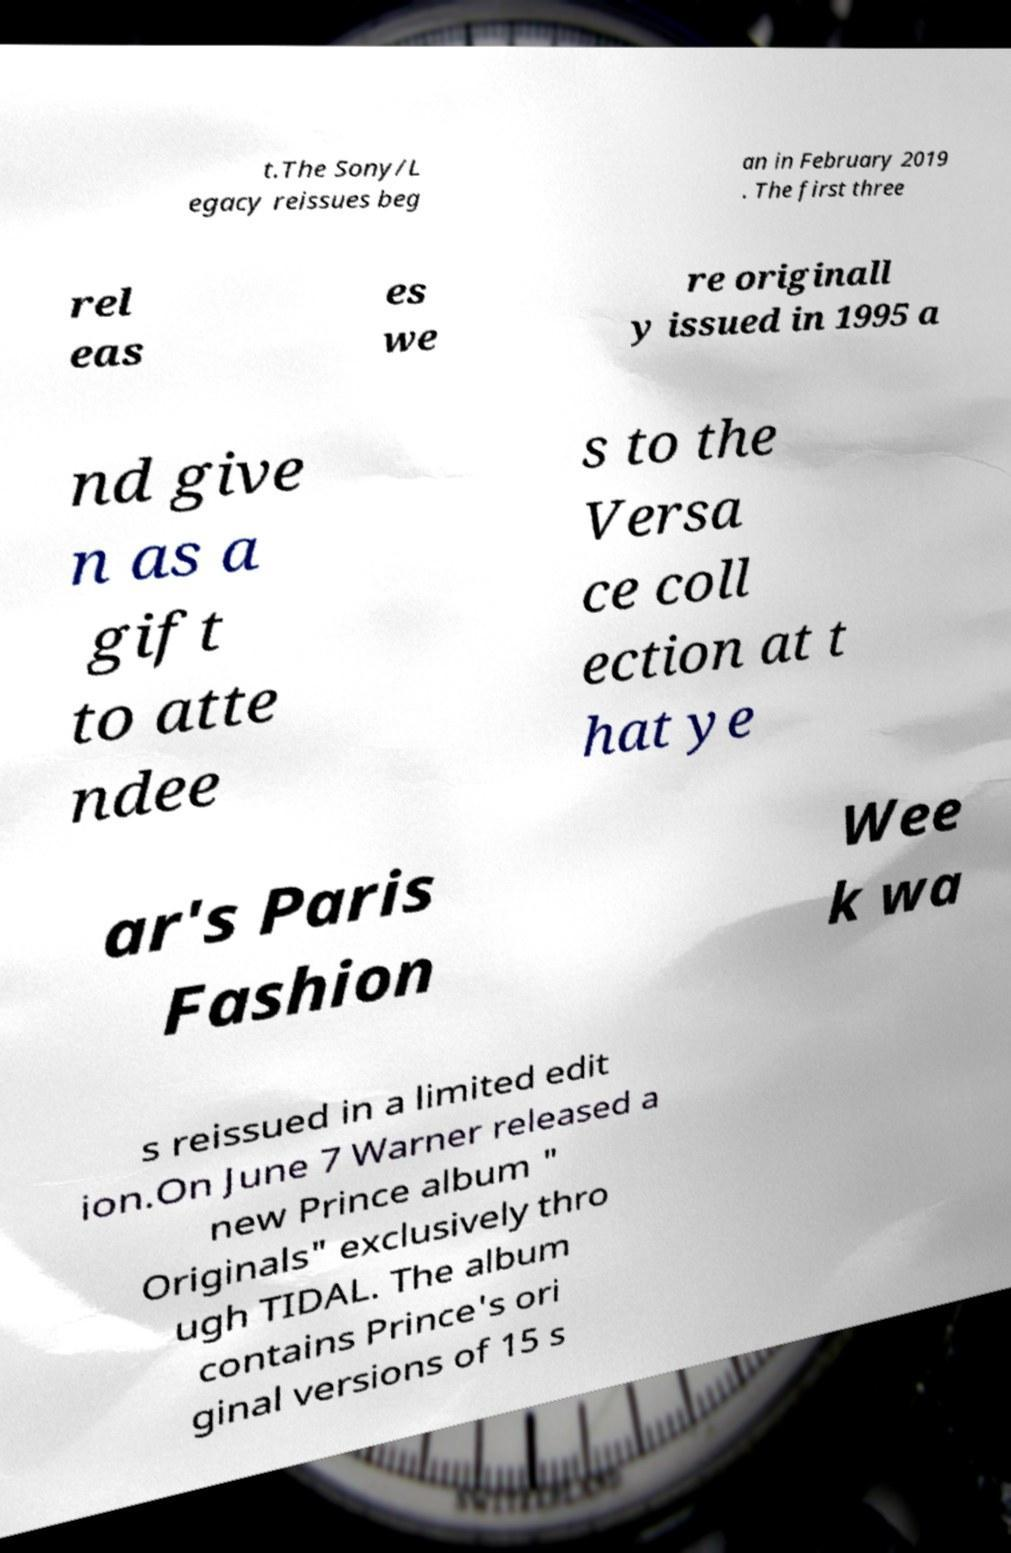Please read and relay the text visible in this image. What does it say? t.The Sony/L egacy reissues beg an in February 2019 . The first three rel eas es we re originall y issued in 1995 a nd give n as a gift to atte ndee s to the Versa ce coll ection at t hat ye ar's Paris Fashion Wee k wa s reissued in a limited edit ion.On June 7 Warner released a new Prince album " Originals" exclusively thro ugh TIDAL. The album contains Prince's ori ginal versions of 15 s 